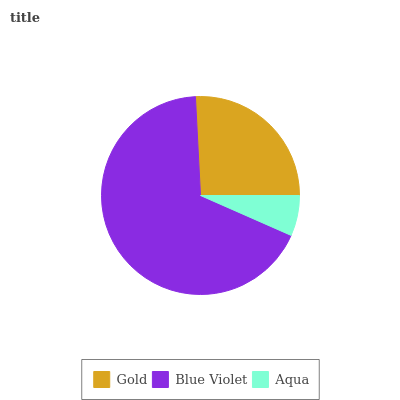Is Aqua the minimum?
Answer yes or no. Yes. Is Blue Violet the maximum?
Answer yes or no. Yes. Is Blue Violet the minimum?
Answer yes or no. No. Is Aqua the maximum?
Answer yes or no. No. Is Blue Violet greater than Aqua?
Answer yes or no. Yes. Is Aqua less than Blue Violet?
Answer yes or no. Yes. Is Aqua greater than Blue Violet?
Answer yes or no. No. Is Blue Violet less than Aqua?
Answer yes or no. No. Is Gold the high median?
Answer yes or no. Yes. Is Gold the low median?
Answer yes or no. Yes. Is Blue Violet the high median?
Answer yes or no. No. Is Aqua the low median?
Answer yes or no. No. 